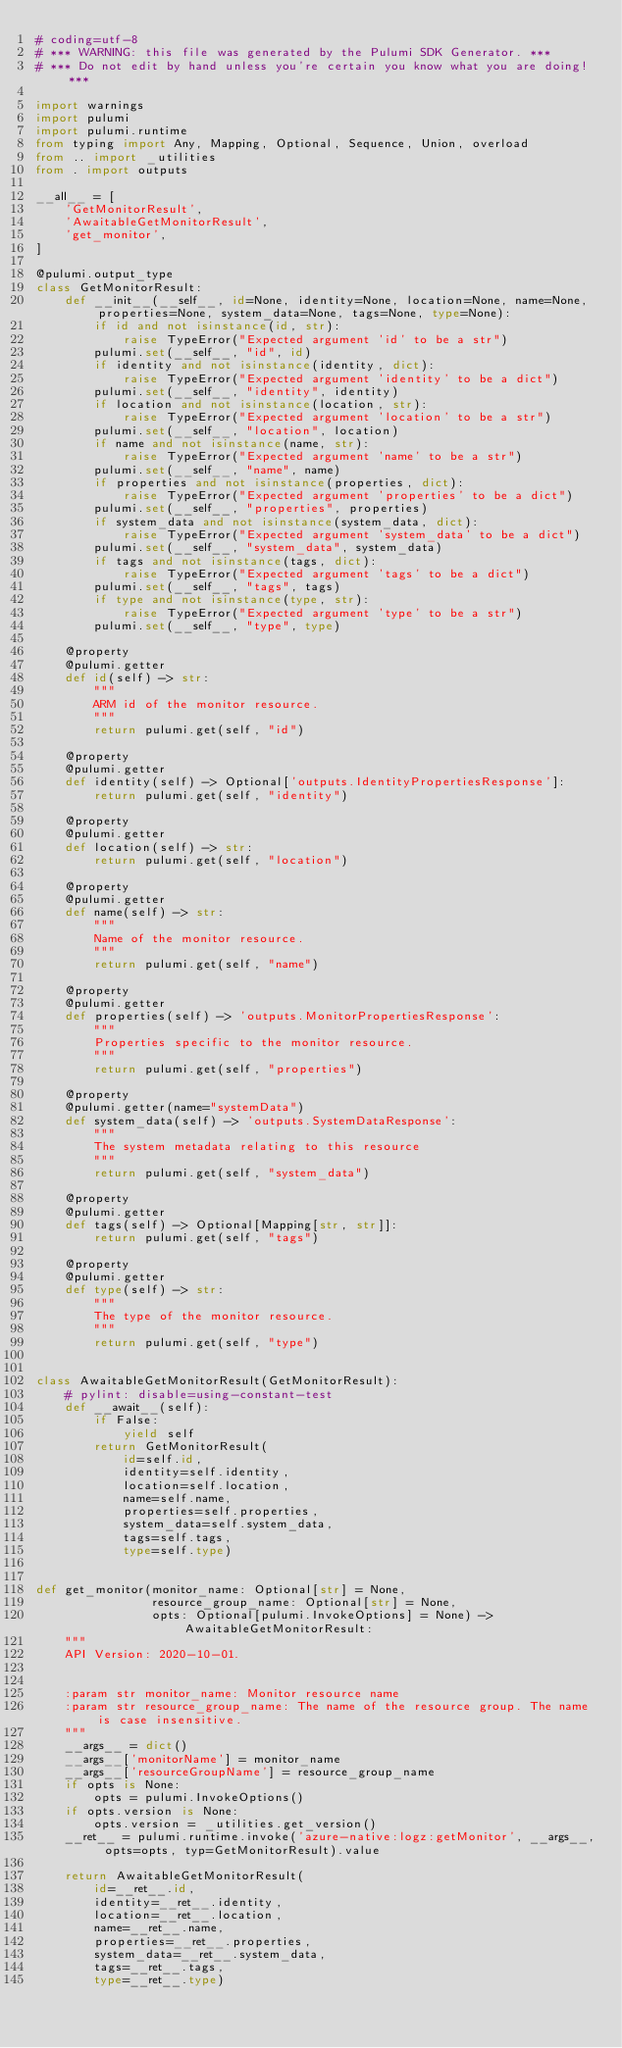Convert code to text. <code><loc_0><loc_0><loc_500><loc_500><_Python_># coding=utf-8
# *** WARNING: this file was generated by the Pulumi SDK Generator. ***
# *** Do not edit by hand unless you're certain you know what you are doing! ***

import warnings
import pulumi
import pulumi.runtime
from typing import Any, Mapping, Optional, Sequence, Union, overload
from .. import _utilities
from . import outputs

__all__ = [
    'GetMonitorResult',
    'AwaitableGetMonitorResult',
    'get_monitor',
]

@pulumi.output_type
class GetMonitorResult:
    def __init__(__self__, id=None, identity=None, location=None, name=None, properties=None, system_data=None, tags=None, type=None):
        if id and not isinstance(id, str):
            raise TypeError("Expected argument 'id' to be a str")
        pulumi.set(__self__, "id", id)
        if identity and not isinstance(identity, dict):
            raise TypeError("Expected argument 'identity' to be a dict")
        pulumi.set(__self__, "identity", identity)
        if location and not isinstance(location, str):
            raise TypeError("Expected argument 'location' to be a str")
        pulumi.set(__self__, "location", location)
        if name and not isinstance(name, str):
            raise TypeError("Expected argument 'name' to be a str")
        pulumi.set(__self__, "name", name)
        if properties and not isinstance(properties, dict):
            raise TypeError("Expected argument 'properties' to be a dict")
        pulumi.set(__self__, "properties", properties)
        if system_data and not isinstance(system_data, dict):
            raise TypeError("Expected argument 'system_data' to be a dict")
        pulumi.set(__self__, "system_data", system_data)
        if tags and not isinstance(tags, dict):
            raise TypeError("Expected argument 'tags' to be a dict")
        pulumi.set(__self__, "tags", tags)
        if type and not isinstance(type, str):
            raise TypeError("Expected argument 'type' to be a str")
        pulumi.set(__self__, "type", type)

    @property
    @pulumi.getter
    def id(self) -> str:
        """
        ARM id of the monitor resource.
        """
        return pulumi.get(self, "id")

    @property
    @pulumi.getter
    def identity(self) -> Optional['outputs.IdentityPropertiesResponse']:
        return pulumi.get(self, "identity")

    @property
    @pulumi.getter
    def location(self) -> str:
        return pulumi.get(self, "location")

    @property
    @pulumi.getter
    def name(self) -> str:
        """
        Name of the monitor resource.
        """
        return pulumi.get(self, "name")

    @property
    @pulumi.getter
    def properties(self) -> 'outputs.MonitorPropertiesResponse':
        """
        Properties specific to the monitor resource.
        """
        return pulumi.get(self, "properties")

    @property
    @pulumi.getter(name="systemData")
    def system_data(self) -> 'outputs.SystemDataResponse':
        """
        The system metadata relating to this resource
        """
        return pulumi.get(self, "system_data")

    @property
    @pulumi.getter
    def tags(self) -> Optional[Mapping[str, str]]:
        return pulumi.get(self, "tags")

    @property
    @pulumi.getter
    def type(self) -> str:
        """
        The type of the monitor resource.
        """
        return pulumi.get(self, "type")


class AwaitableGetMonitorResult(GetMonitorResult):
    # pylint: disable=using-constant-test
    def __await__(self):
        if False:
            yield self
        return GetMonitorResult(
            id=self.id,
            identity=self.identity,
            location=self.location,
            name=self.name,
            properties=self.properties,
            system_data=self.system_data,
            tags=self.tags,
            type=self.type)


def get_monitor(monitor_name: Optional[str] = None,
                resource_group_name: Optional[str] = None,
                opts: Optional[pulumi.InvokeOptions] = None) -> AwaitableGetMonitorResult:
    """
    API Version: 2020-10-01.


    :param str monitor_name: Monitor resource name
    :param str resource_group_name: The name of the resource group. The name is case insensitive.
    """
    __args__ = dict()
    __args__['monitorName'] = monitor_name
    __args__['resourceGroupName'] = resource_group_name
    if opts is None:
        opts = pulumi.InvokeOptions()
    if opts.version is None:
        opts.version = _utilities.get_version()
    __ret__ = pulumi.runtime.invoke('azure-native:logz:getMonitor', __args__, opts=opts, typ=GetMonitorResult).value

    return AwaitableGetMonitorResult(
        id=__ret__.id,
        identity=__ret__.identity,
        location=__ret__.location,
        name=__ret__.name,
        properties=__ret__.properties,
        system_data=__ret__.system_data,
        tags=__ret__.tags,
        type=__ret__.type)
</code> 